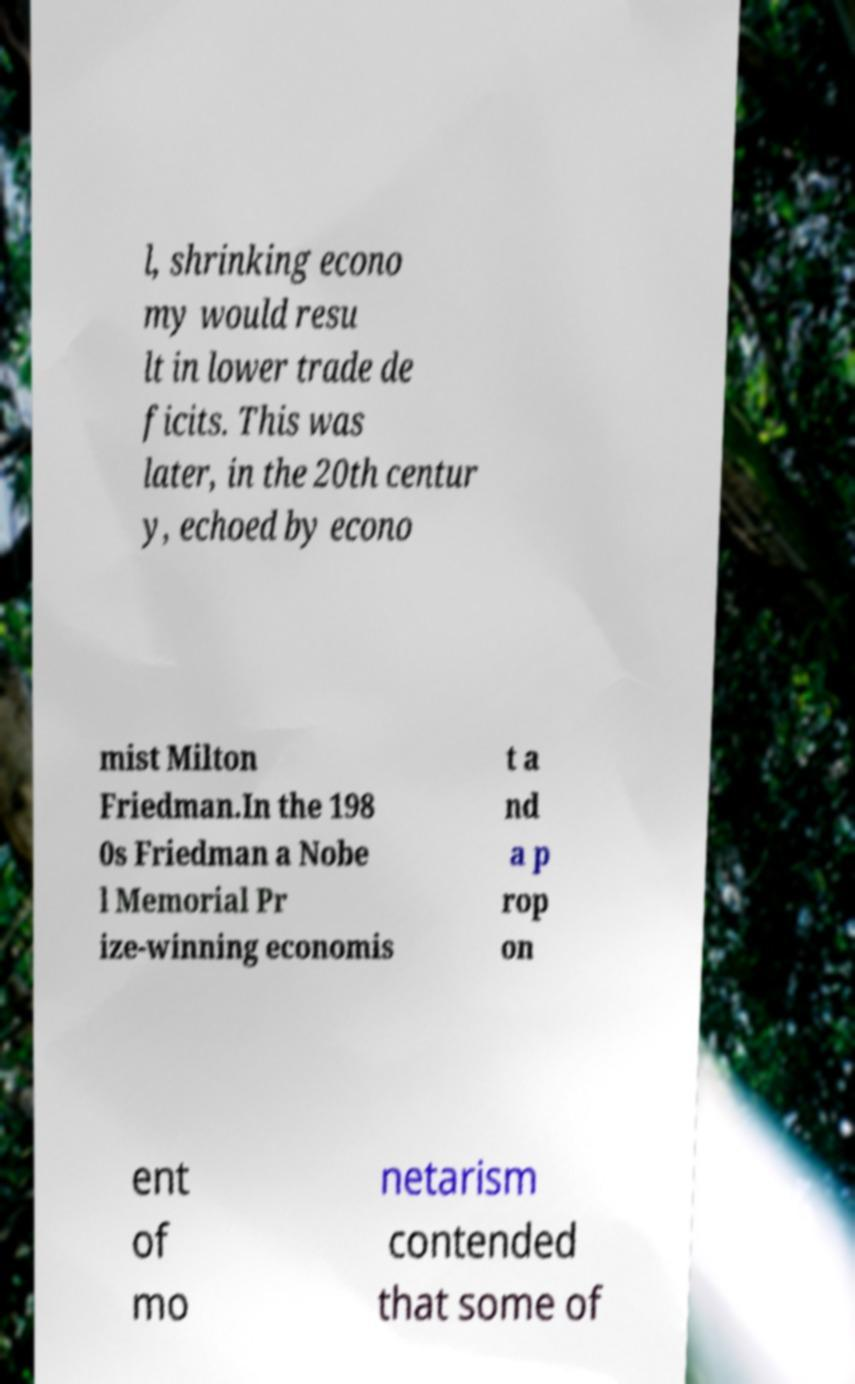Could you assist in decoding the text presented in this image and type it out clearly? l, shrinking econo my would resu lt in lower trade de ficits. This was later, in the 20th centur y, echoed by econo mist Milton Friedman.In the 198 0s Friedman a Nobe l Memorial Pr ize-winning economis t a nd a p rop on ent of mo netarism contended that some of 